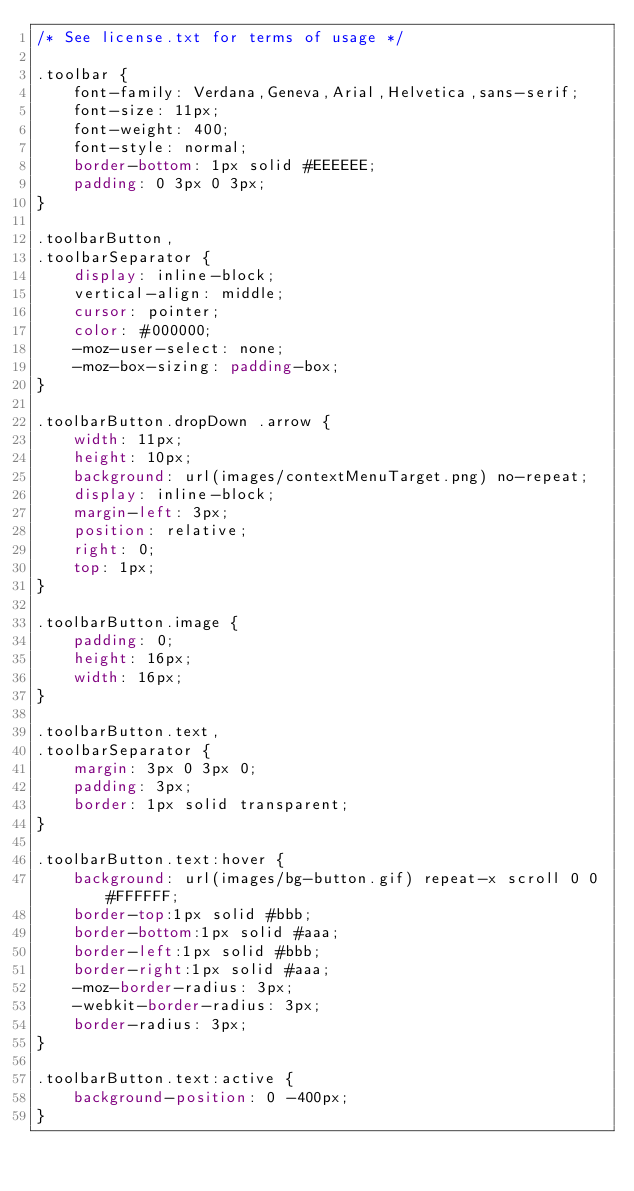Convert code to text. <code><loc_0><loc_0><loc_500><loc_500><_CSS_>/* See license.txt for terms of usage */

.toolbar {
    font-family: Verdana,Geneva,Arial,Helvetica,sans-serif;
    font-size: 11px;
    font-weight: 400;
    font-style: normal;
    border-bottom: 1px solid #EEEEEE;
    padding: 0 3px 0 3px;
}

.toolbarButton,
.toolbarSeparator {
    display: inline-block;
    vertical-align: middle;
    cursor: pointer;
    color: #000000;
    -moz-user-select: none;
    -moz-box-sizing: padding-box;
}

.toolbarButton.dropDown .arrow {
    width: 11px;
    height: 10px;
    background: url(images/contextMenuTarget.png) no-repeat;
    display: inline-block;
    margin-left: 3px;
    position: relative;
    right: 0;
    top: 1px;
}

.toolbarButton.image {
    padding: 0;
    height: 16px;
    width: 16px;
}

.toolbarButton.text,
.toolbarSeparator {
    margin: 3px 0 3px 0;
    padding: 3px;
    border: 1px solid transparent;
}

.toolbarButton.text:hover {
    background: url(images/bg-button.gif) repeat-x scroll 0 0 #FFFFFF;
    border-top:1px solid #bbb;
    border-bottom:1px solid #aaa;
    border-left:1px solid #bbb;
    border-right:1px solid #aaa;
    -moz-border-radius: 3px;
    -webkit-border-radius: 3px;
    border-radius: 3px;
}

.toolbarButton.text:active {
    background-position: 0 -400px;
}
</code> 